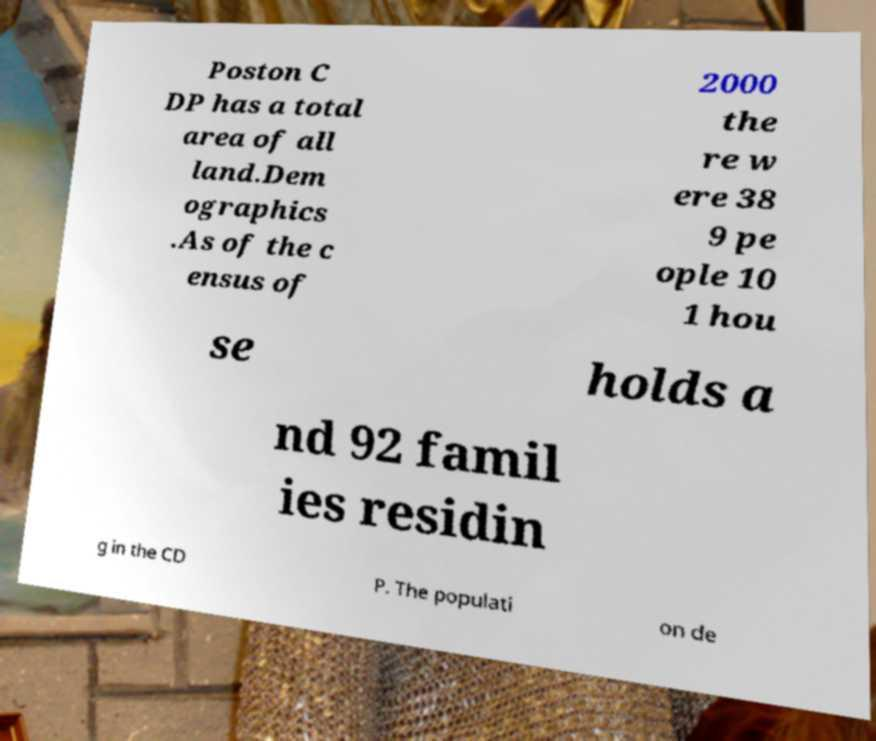Can you accurately transcribe the text from the provided image for me? Poston C DP has a total area of all land.Dem ographics .As of the c ensus of 2000 the re w ere 38 9 pe ople 10 1 hou se holds a nd 92 famil ies residin g in the CD P. The populati on de 